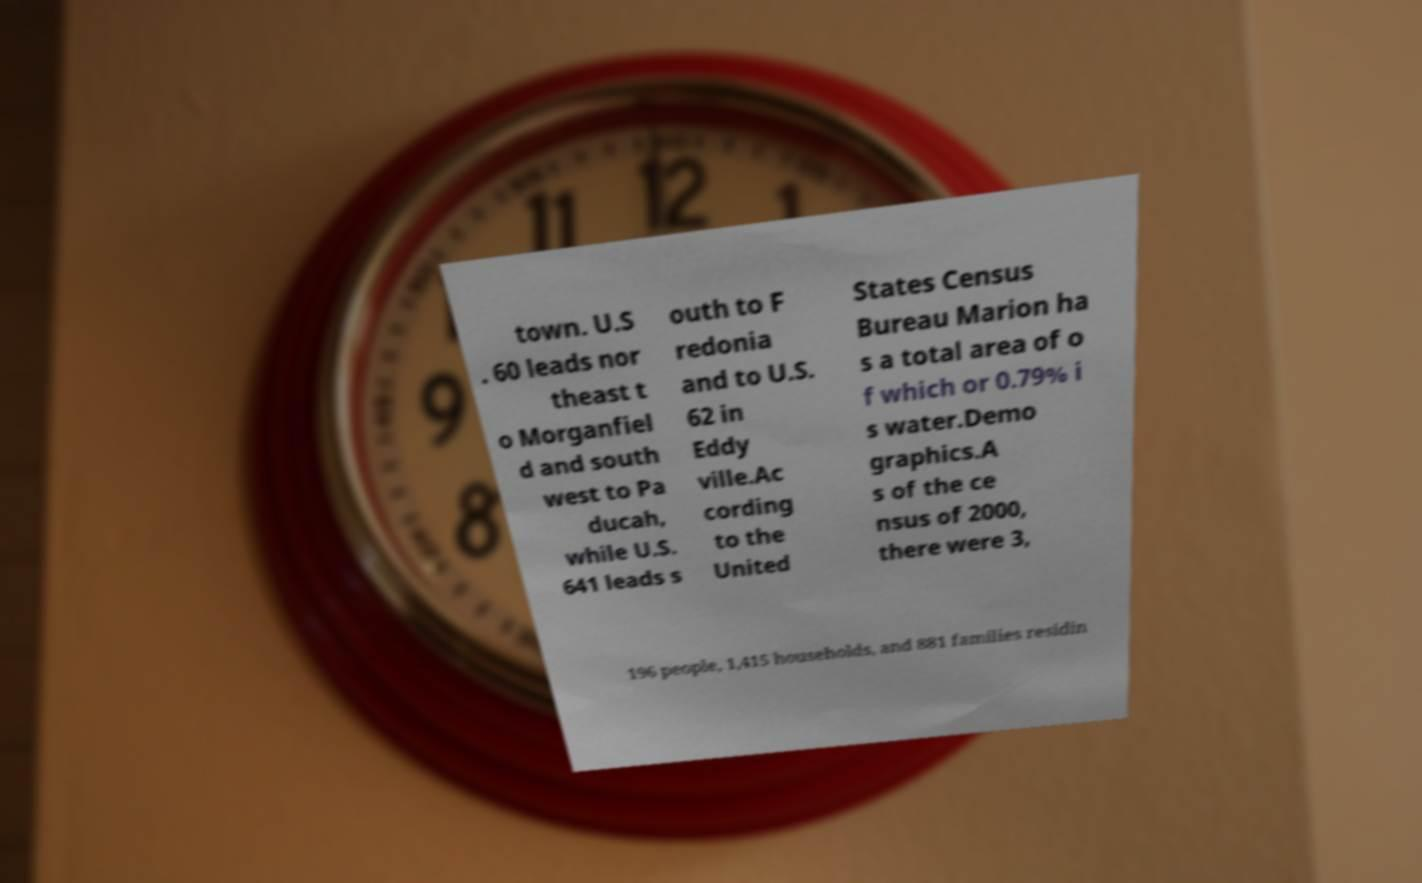Can you accurately transcribe the text from the provided image for me? town. U.S . 60 leads nor theast t o Morganfiel d and south west to Pa ducah, while U.S. 641 leads s outh to F redonia and to U.S. 62 in Eddy ville.Ac cording to the United States Census Bureau Marion ha s a total area of o f which or 0.79% i s water.Demo graphics.A s of the ce nsus of 2000, there were 3, 196 people, 1,415 households, and 881 families residin 